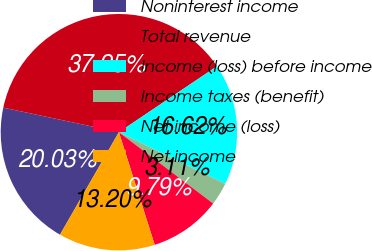<chart> <loc_0><loc_0><loc_500><loc_500><pie_chart><fcel>Noninterest income<fcel>Total revenue<fcel>Income (loss) before income<fcel>Income taxes (benefit)<fcel>Net income (loss)<fcel>Net income<nl><fcel>20.03%<fcel>37.25%<fcel>16.62%<fcel>3.11%<fcel>9.79%<fcel>13.2%<nl></chart> 